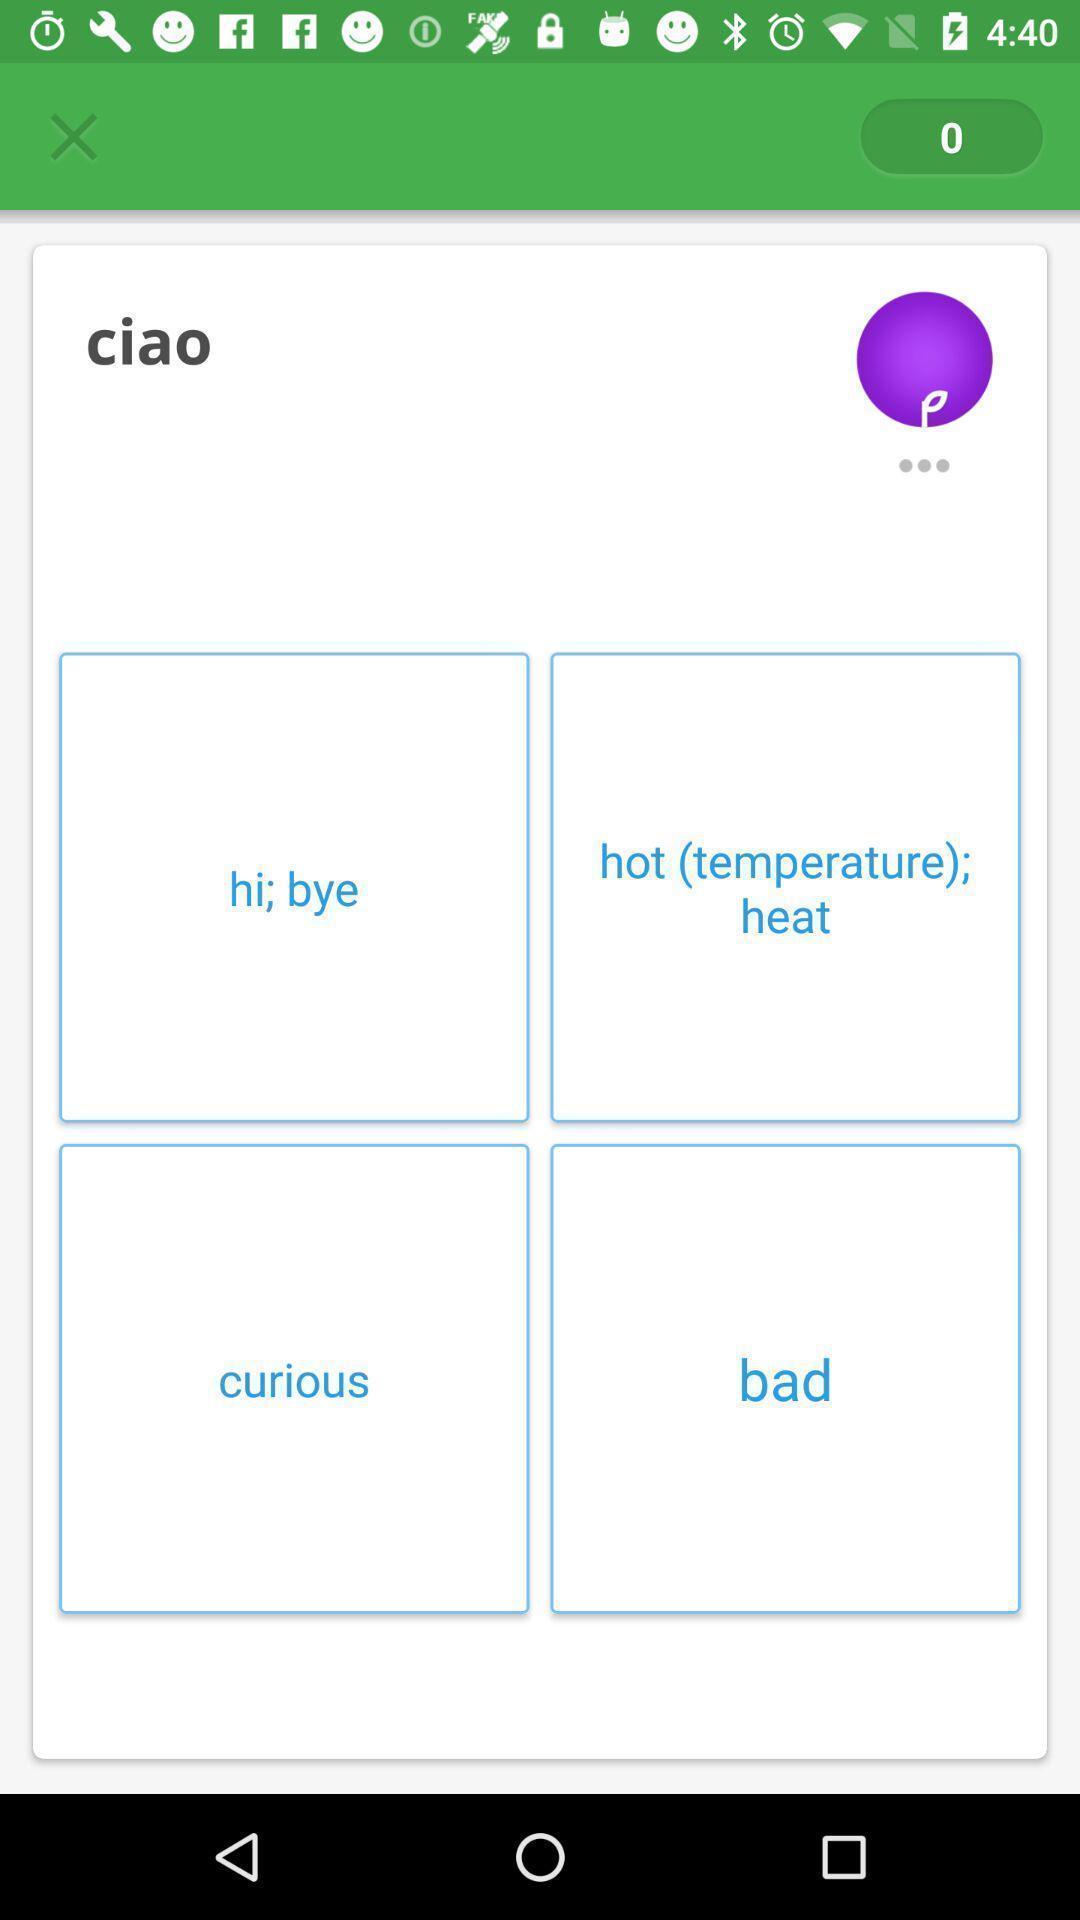Explain the elements present in this screenshot. Screen page displaying various text with cancel icon. 